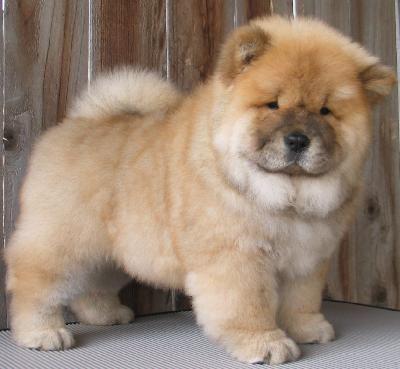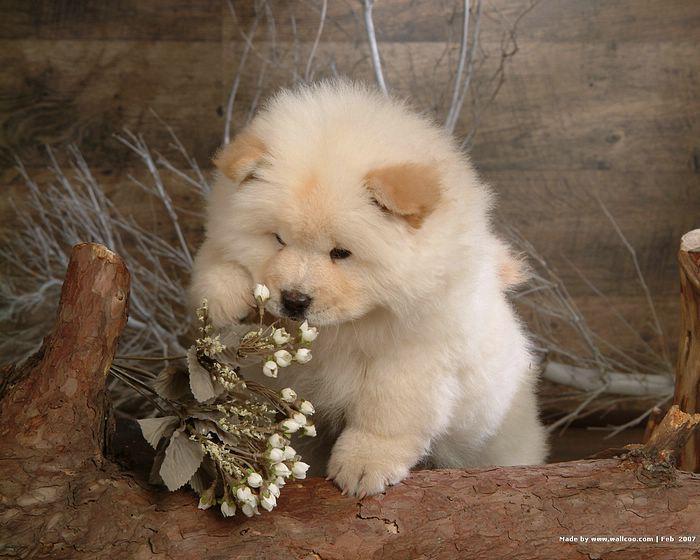The first image is the image on the left, the second image is the image on the right. For the images shown, is this caption "A dog is eating food." true? Answer yes or no. No. The first image is the image on the left, the second image is the image on the right. For the images displayed, is the sentence "there are 3 dogs in the image pair" factually correct? Answer yes or no. No. 